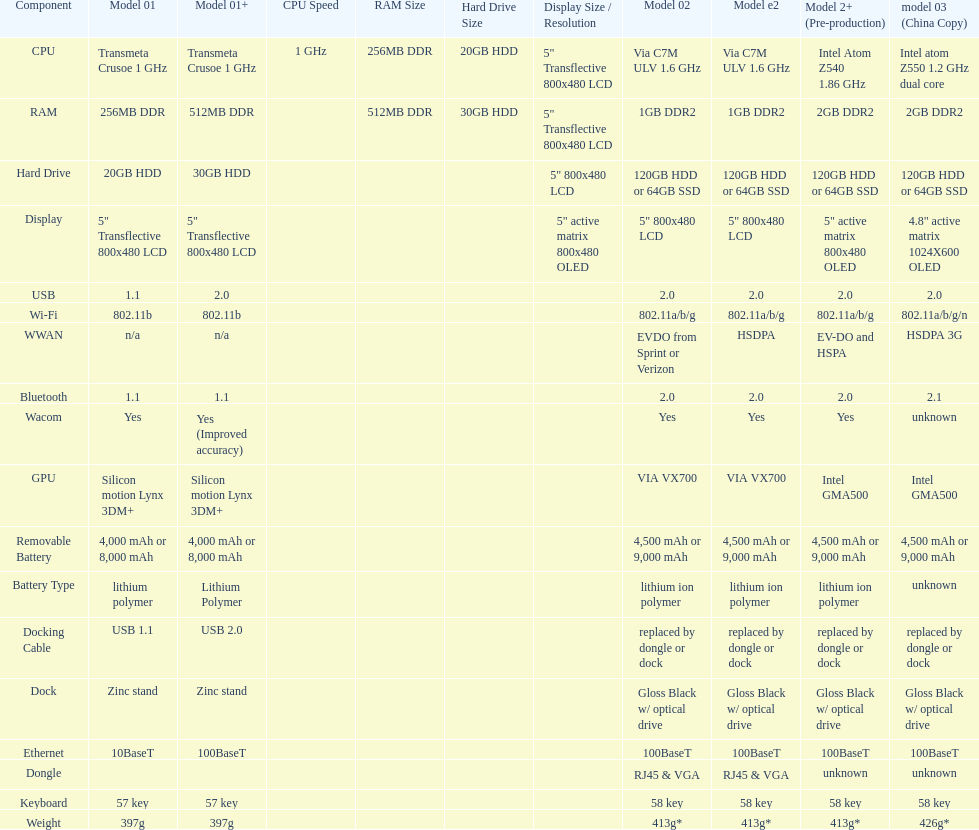Are there at least 13 different components on the chart? Yes. 